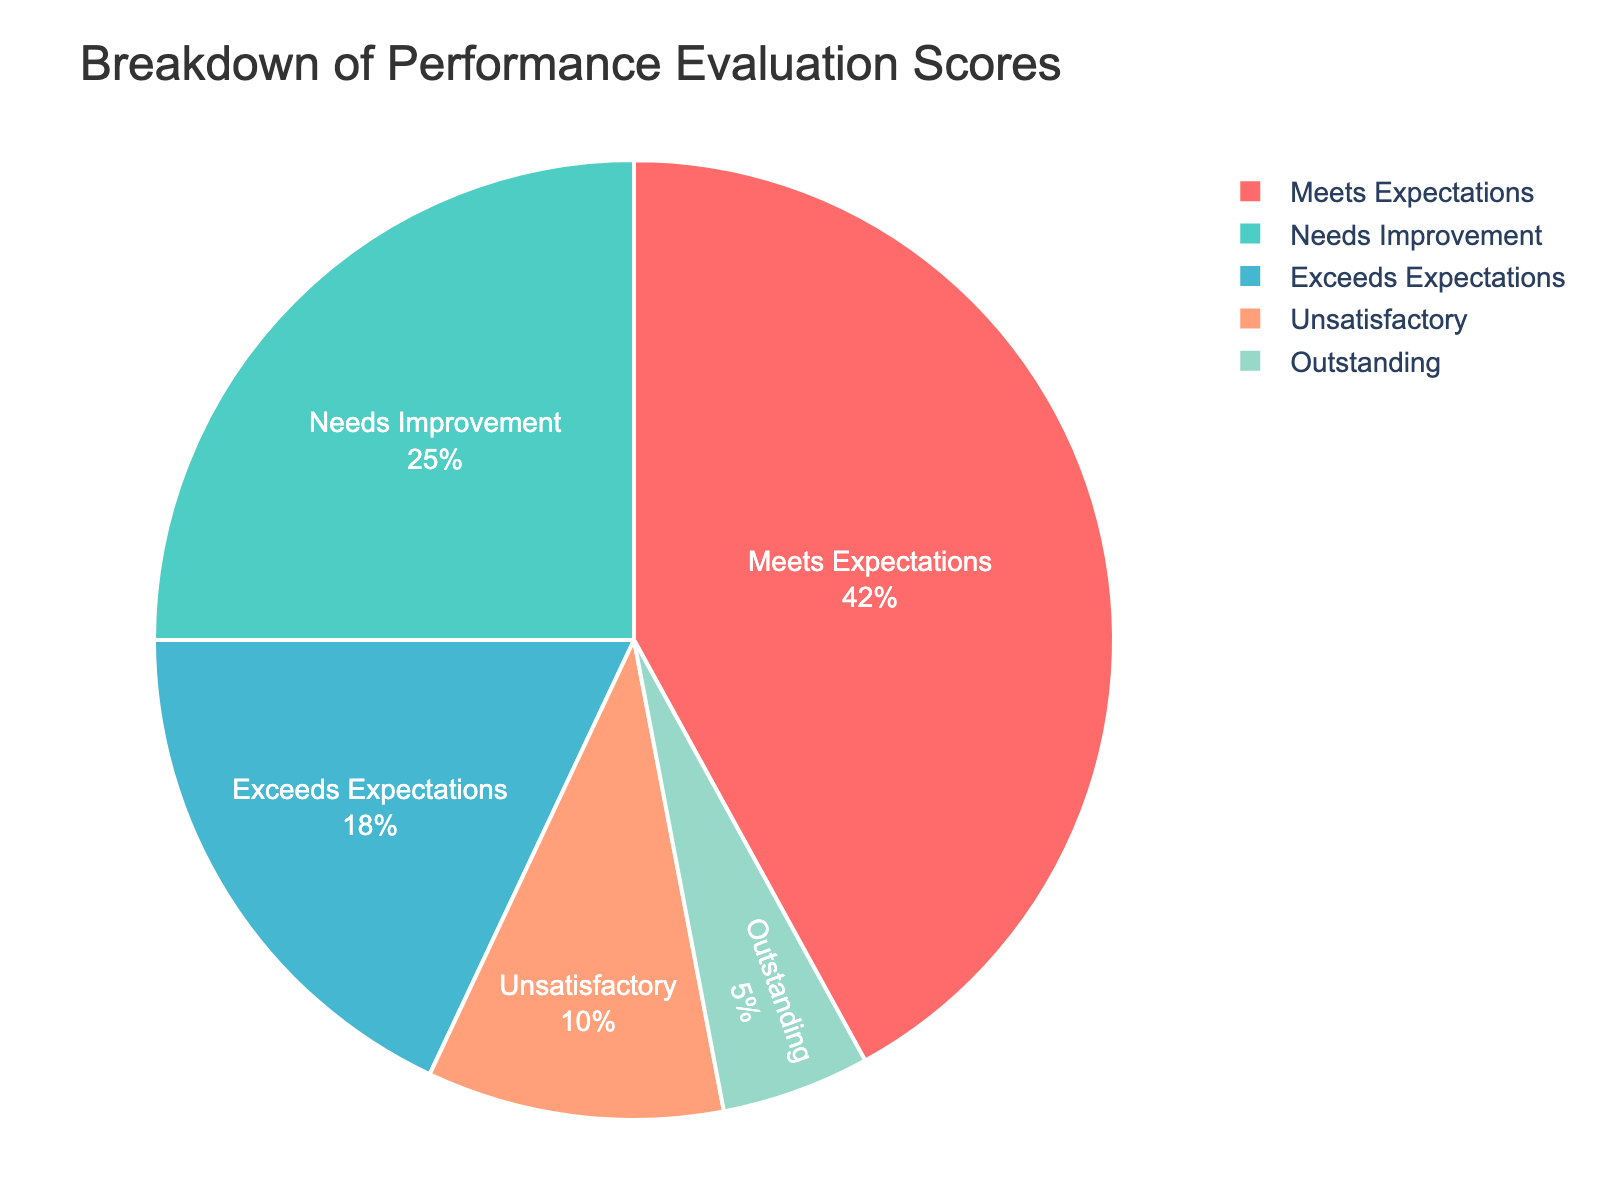What percentage of staff met or exceeded expectations? To find the percentage of staff who met or exceeded expectations, add the percentages for "Meets Expectations" and "Exceeds Expectations". So, 42% (Meets Expectations) + 18% (Exceeds Expectations) = 60%.
Answer: 60% What is the smallest category of performance evaluation scores? Look at the pie chart and identify the category with the smallest percentage. The "Outstanding" category has the smallest slice at 5%.
Answer: Outstanding Which category has the highest percentage among the performance evaluation scores? Check the pie chart and find the category with the largest slice. The "Meets Expectations" category has the highest percentage at 42%.
Answer: Meets Expectations How much larger is the "Needs Improvement" category compared to the "Outstanding" category? Subtract the percentage of the "Outstanding" category from the "Needs Improvement" category. So, 25% (Needs Improvement) - 5% (Outstanding) = 20%.
Answer: 20% If 200 staff members were evaluated, how many received an "Exceeds Expectations" rating? First, find the percentage of staff that received an "Exceeds Expectations" rating, which is 18%. Then multiply by the total number of staff: 200 * 0.18 = 36.
Answer: 36 What percentage of staff had scores that were either "Needs Improvement" or "Unsatisfactory"? Add the percentages for "Needs Improvement" and "Unsatisfactory", which are 25% and 10%, respectively. So, 25% + 10% = 35%.
Answer: 35% Is the combined percentage of "Unsatisfactory" and "Outstanding" greater than the "Needs Improvement" category? Add the percentages of "Unsatisfactory" (10%) and "Outstanding" (5%) and compare it to "Needs Improvement" (25%). So, 10% + 5% = 15%, which is less than 25%.
Answer: No How much greater is the "Meets Expectations" category compared to the sum of "Unsatisfactory" and "Outstanding"? First, add the "Unsatisfactory" and "Outstanding" percentages: 10% + 5% = 15%. Then subtract this from the "Meets Expectations" category: 42% - 15% = 27%.
Answer: 27% What is the total percentage of staff that did not meet expectations? Combine the percentages of "Needs Improvement" and "Unsatisfactory", which are 25% and 10% respectively. So, 25% + 10% = 35%.
Answer: 35% Comparing "Exceeds Expectations" and "Outstanding," which category has a smaller percentage, and by how much? Compare the percentages of "Exceeds Expectations" (18%) and "Outstanding" (5%), and find the difference: 18% - 5% = 13%. "Outstanding" is smaller by 13%.
Answer: Outstanding, by 13% 